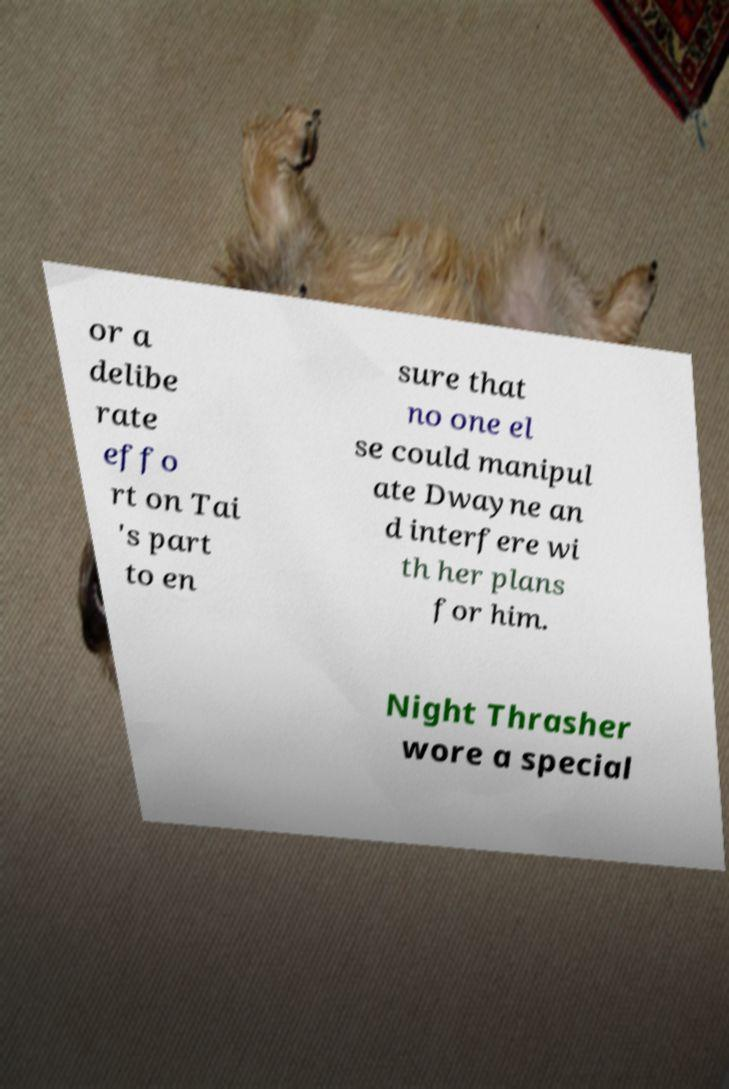For documentation purposes, I need the text within this image transcribed. Could you provide that? or a delibe rate effo rt on Tai 's part to en sure that no one el se could manipul ate Dwayne an d interfere wi th her plans for him. Night Thrasher wore a special 